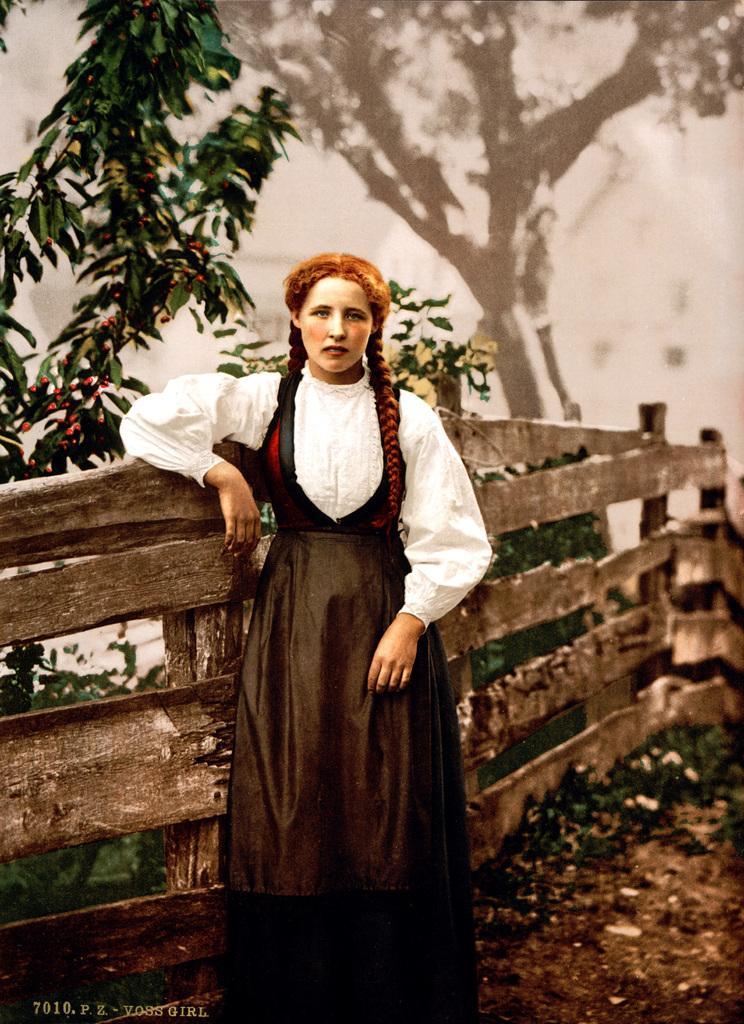What is the main subject of the image? There is a woman standing in the image. What is the woman doing in the image? The woman is posing for a photo. What type of structure can be seen in the image? There is a wooden fence in the image. What type of natural elements are visible in the image? There are plants and trees visible in the image. What type of anger is the woman expressing in the image? The image does not show the woman expressing any anger; she is posing for a photo. Is there a lawyer present in the image? There is no mention of a lawyer in the image or the provided facts. 